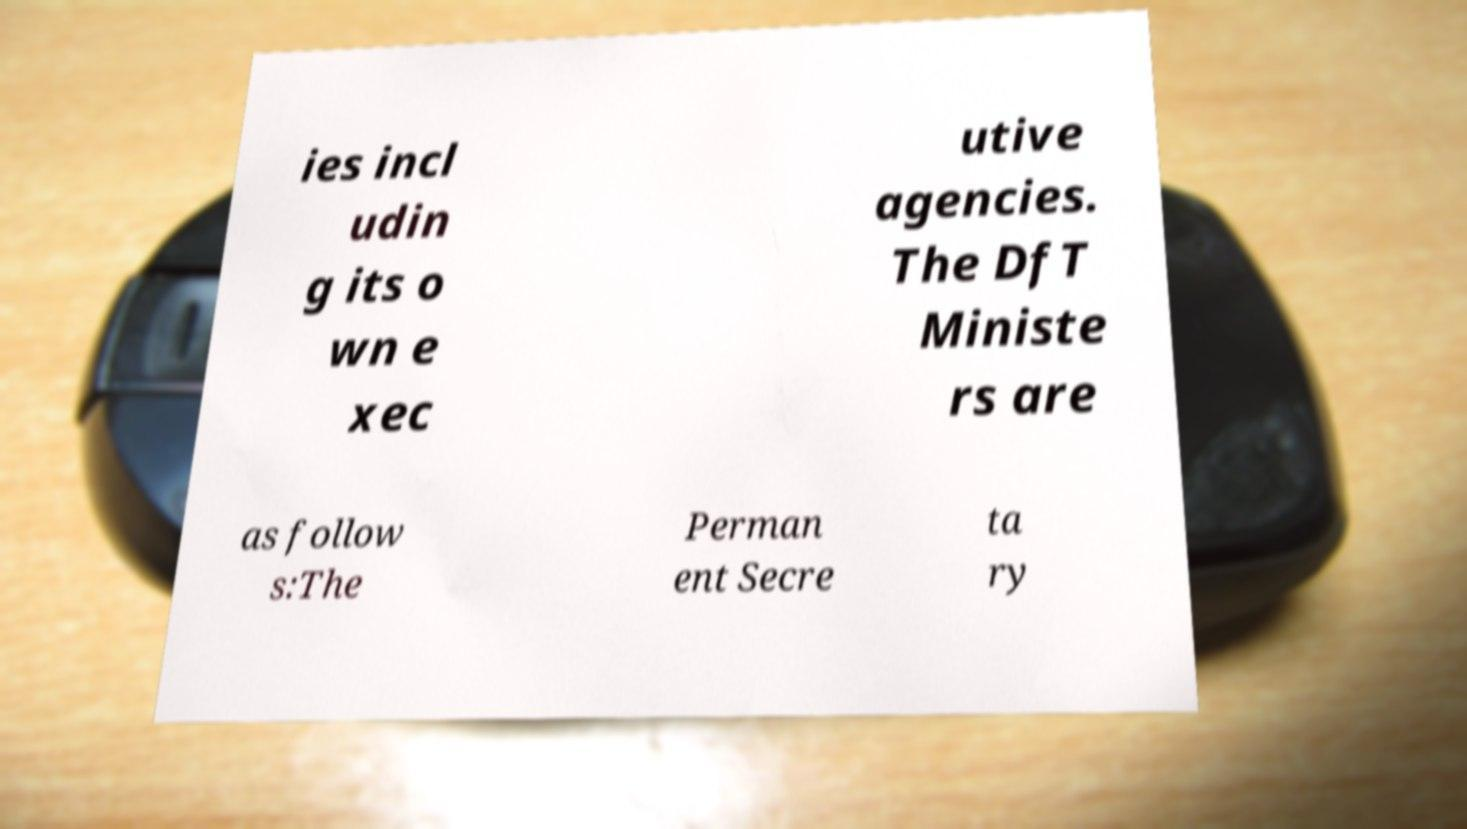Can you read and provide the text displayed in the image?This photo seems to have some interesting text. Can you extract and type it out for me? ies incl udin g its o wn e xec utive agencies. The DfT Ministe rs are as follow s:The Perman ent Secre ta ry 